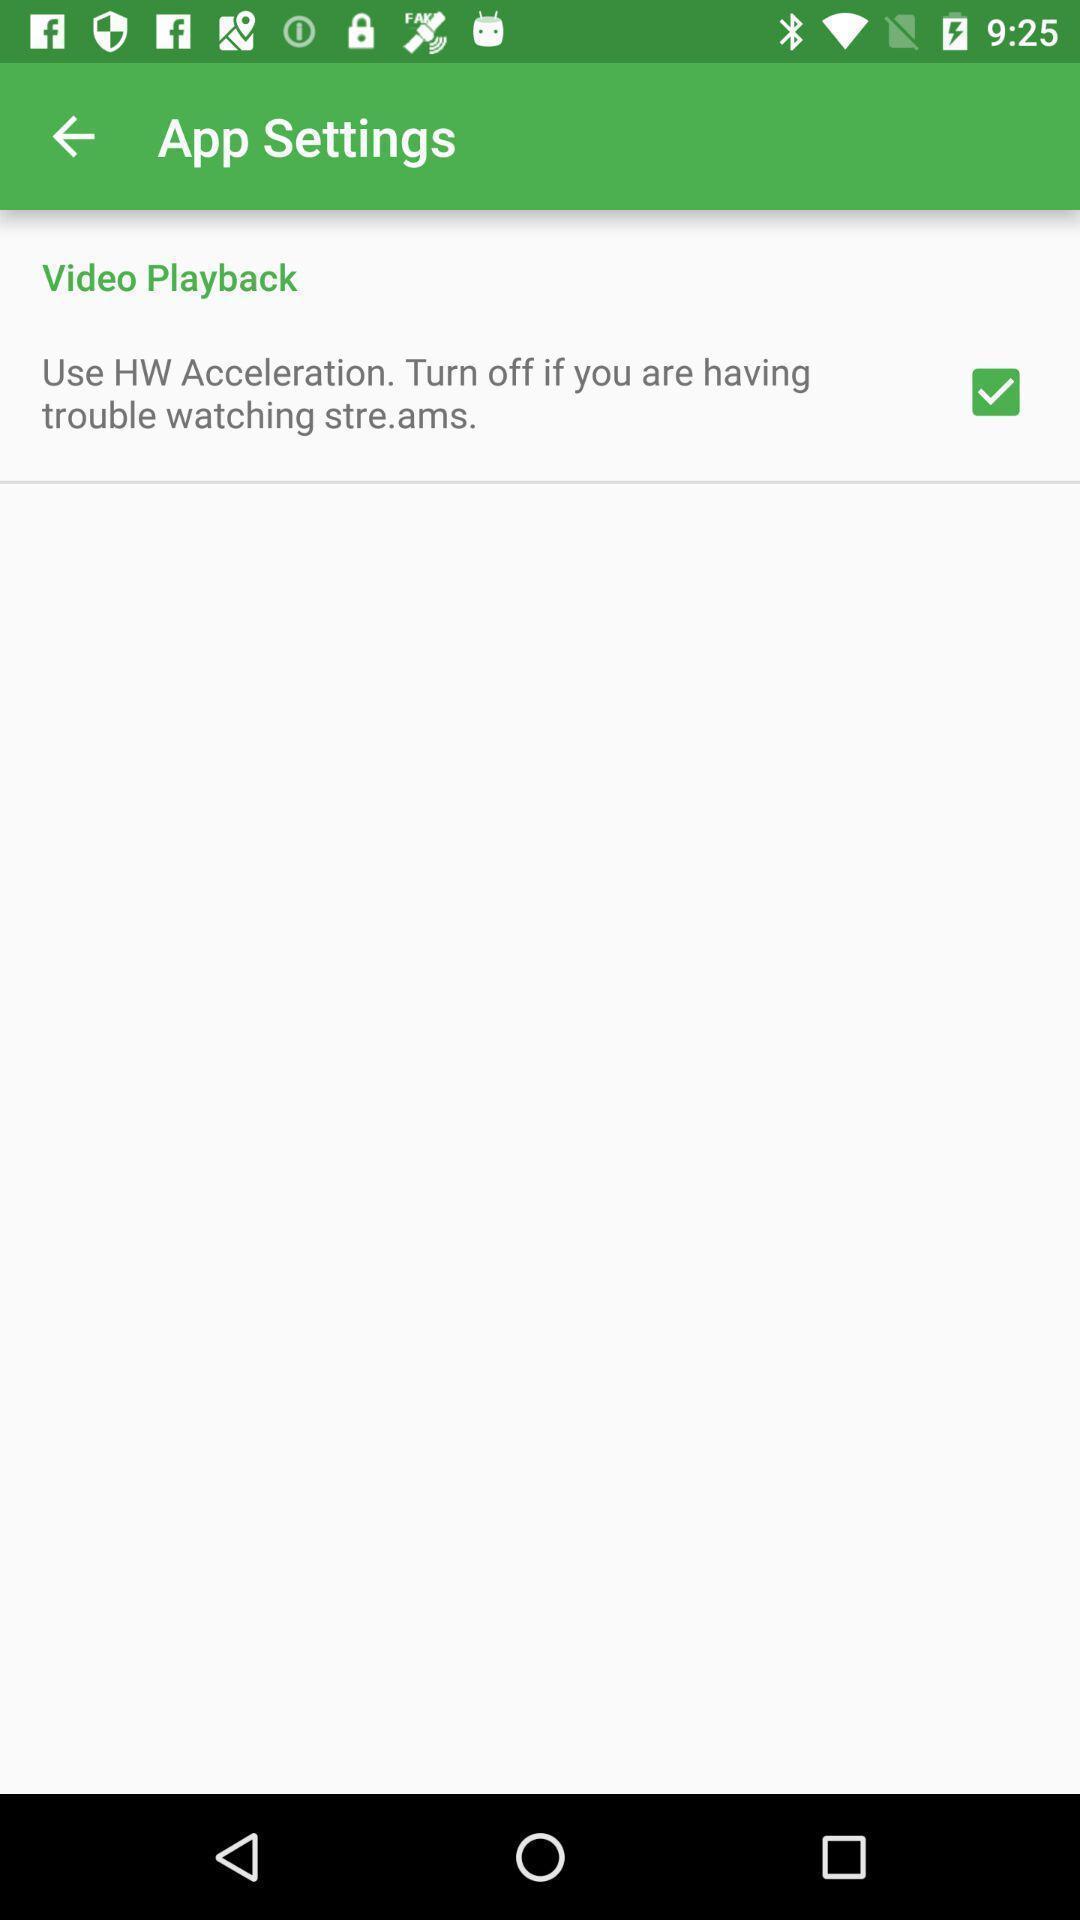What is the overall content of this screenshot? Settings page displayed of an streaming application. 